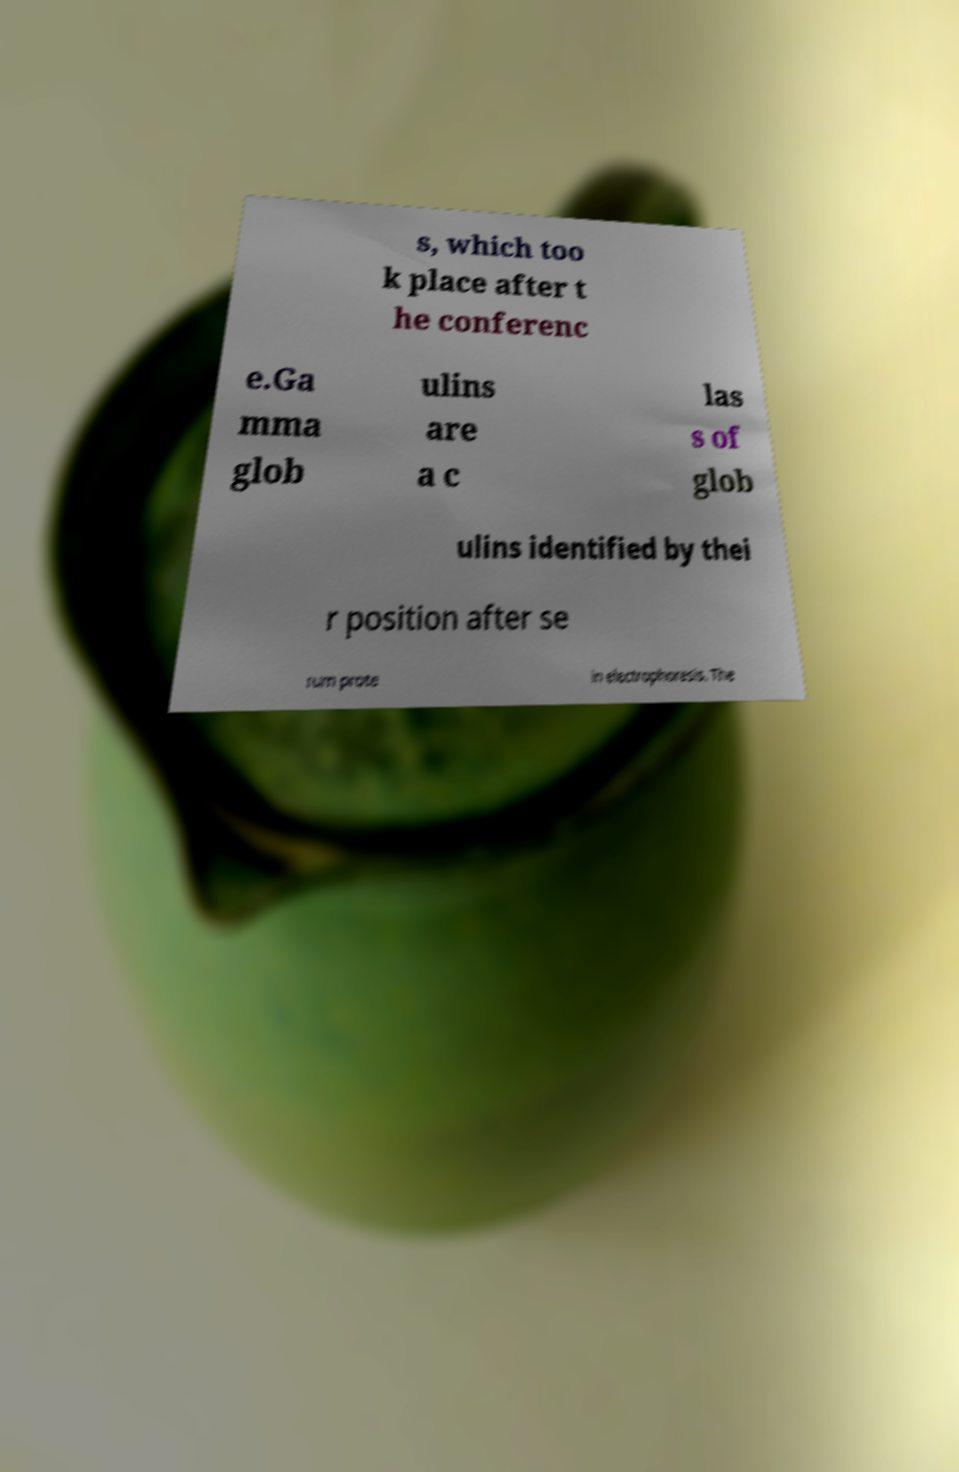What messages or text are displayed in this image? I need them in a readable, typed format. s, which too k place after t he conferenc e.Ga mma glob ulins are a c las s of glob ulins identified by thei r position after se rum prote in electrophoresis. The 